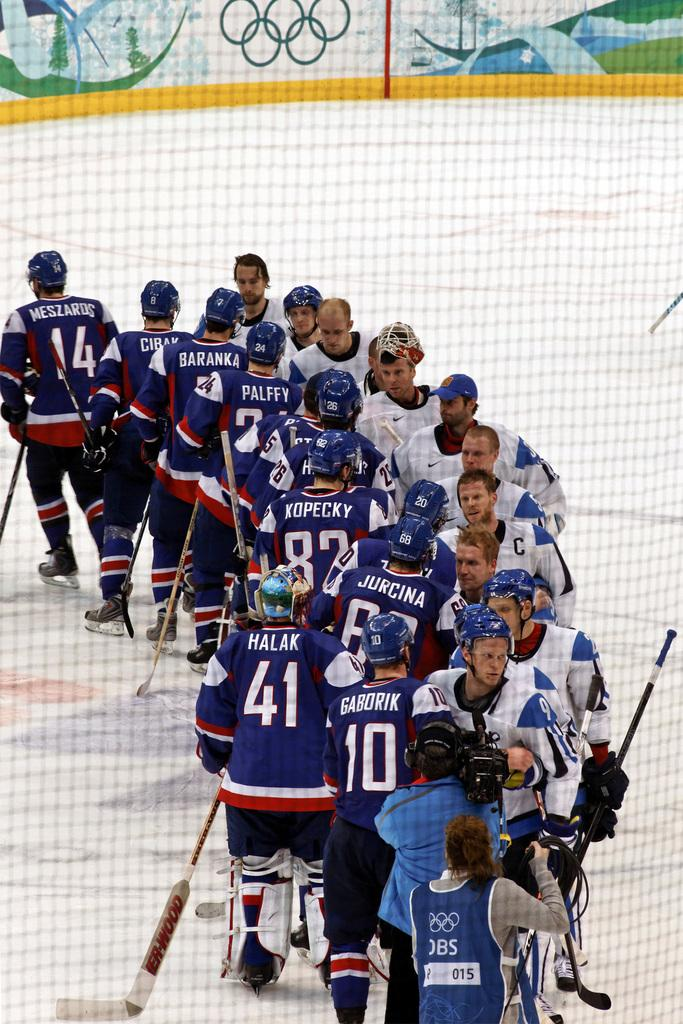<image>
Give a short and clear explanation of the subsequent image. Hockey players in white shirts and Reebok sponsored helmets are lined up to shake the hands of the opposing team. 